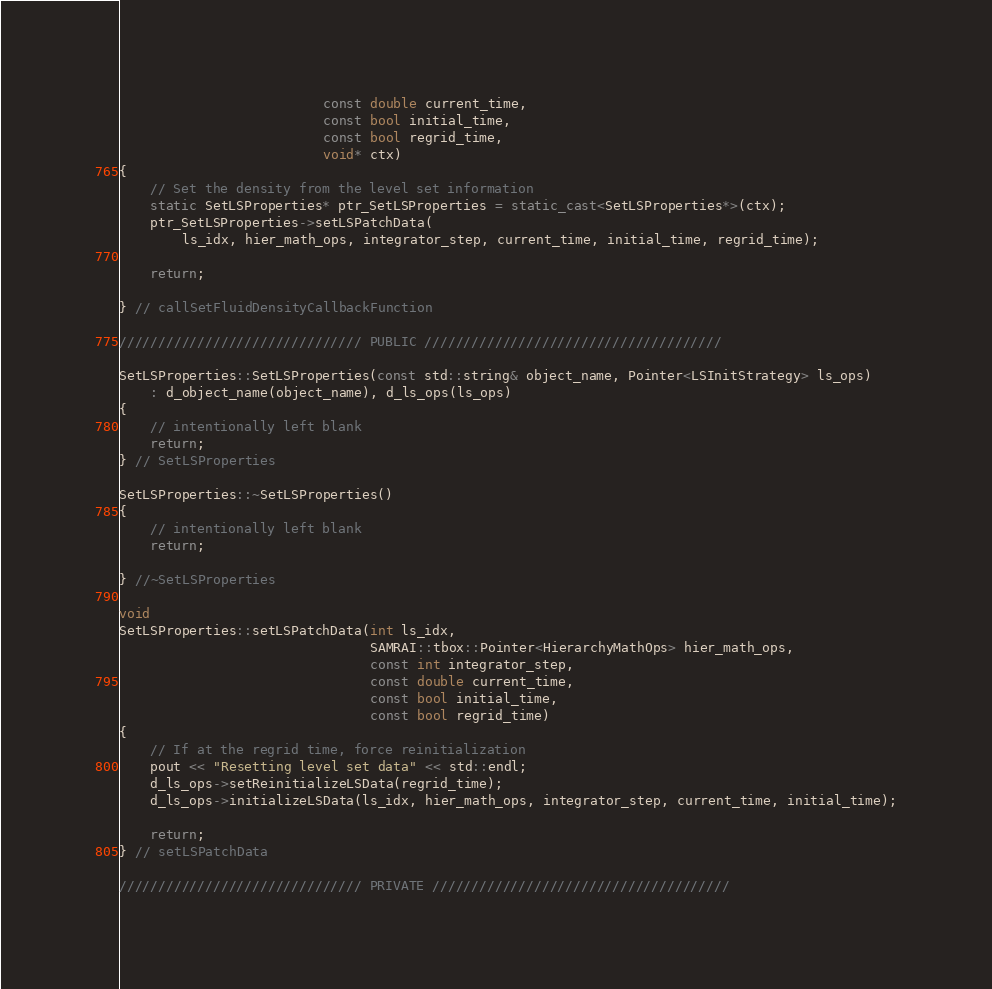Convert code to text. <code><loc_0><loc_0><loc_500><loc_500><_C++_>                          const double current_time,
                          const bool initial_time,
                          const bool regrid_time,
                          void* ctx)
{
    // Set the density from the level set information
    static SetLSProperties* ptr_SetLSProperties = static_cast<SetLSProperties*>(ctx);
    ptr_SetLSProperties->setLSPatchData(
        ls_idx, hier_math_ops, integrator_step, current_time, initial_time, regrid_time);

    return;

} // callSetFluidDensityCallbackFunction

/////////////////////////////// PUBLIC //////////////////////////////////////

SetLSProperties::SetLSProperties(const std::string& object_name, Pointer<LSInitStrategy> ls_ops)
    : d_object_name(object_name), d_ls_ops(ls_ops)
{
    // intentionally left blank
    return;
} // SetLSProperties

SetLSProperties::~SetLSProperties()
{
    // intentionally left blank
    return;

} //~SetLSProperties

void
SetLSProperties::setLSPatchData(int ls_idx,
                                SAMRAI::tbox::Pointer<HierarchyMathOps> hier_math_ops,
                                const int integrator_step,
                                const double current_time,
                                const bool initial_time,
                                const bool regrid_time)
{
    // If at the regrid time, force reinitialization
    pout << "Resetting level set data" << std::endl;
    d_ls_ops->setReinitializeLSData(regrid_time);
    d_ls_ops->initializeLSData(ls_idx, hier_math_ops, integrator_step, current_time, initial_time);

    return;
} // setLSPatchData

/////////////////////////////// PRIVATE //////////////////////////////////////
</code> 